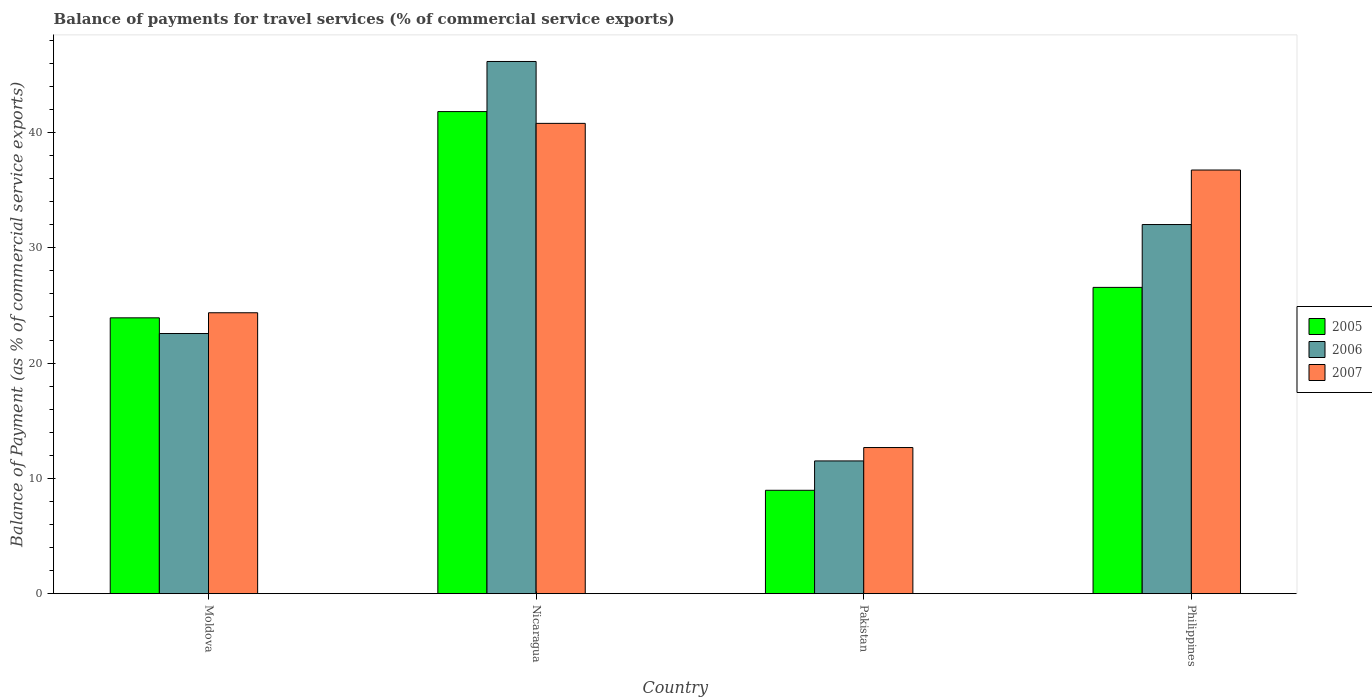Are the number of bars on each tick of the X-axis equal?
Provide a short and direct response. Yes. How many bars are there on the 3rd tick from the left?
Provide a succinct answer. 3. What is the label of the 1st group of bars from the left?
Your answer should be very brief. Moldova. In how many cases, is the number of bars for a given country not equal to the number of legend labels?
Your response must be concise. 0. What is the balance of payments for travel services in 2005 in Nicaragua?
Provide a short and direct response. 41.81. Across all countries, what is the maximum balance of payments for travel services in 2005?
Your answer should be very brief. 41.81. Across all countries, what is the minimum balance of payments for travel services in 2005?
Your answer should be very brief. 8.97. In which country was the balance of payments for travel services in 2005 maximum?
Your response must be concise. Nicaragua. What is the total balance of payments for travel services in 2006 in the graph?
Keep it short and to the point. 112.25. What is the difference between the balance of payments for travel services in 2007 in Moldova and that in Philippines?
Offer a very short reply. -12.38. What is the difference between the balance of payments for travel services in 2007 in Philippines and the balance of payments for travel services in 2005 in Moldova?
Your answer should be very brief. 12.82. What is the average balance of payments for travel services in 2006 per country?
Offer a terse response. 28.06. What is the difference between the balance of payments for travel services of/in 2007 and balance of payments for travel services of/in 2006 in Pakistan?
Offer a very short reply. 1.16. In how many countries, is the balance of payments for travel services in 2006 greater than 6 %?
Your answer should be very brief. 4. What is the ratio of the balance of payments for travel services in 2005 in Pakistan to that in Philippines?
Offer a terse response. 0.34. Is the balance of payments for travel services in 2005 in Pakistan less than that in Philippines?
Keep it short and to the point. Yes. What is the difference between the highest and the second highest balance of payments for travel services in 2005?
Provide a succinct answer. 15.25. What is the difference between the highest and the lowest balance of payments for travel services in 2005?
Provide a short and direct response. 32.85. In how many countries, is the balance of payments for travel services in 2007 greater than the average balance of payments for travel services in 2007 taken over all countries?
Make the answer very short. 2. Is the sum of the balance of payments for travel services in 2007 in Pakistan and Philippines greater than the maximum balance of payments for travel services in 2006 across all countries?
Give a very brief answer. Yes. What does the 3rd bar from the right in Philippines represents?
Ensure brevity in your answer.  2005. Is it the case that in every country, the sum of the balance of payments for travel services in 2005 and balance of payments for travel services in 2007 is greater than the balance of payments for travel services in 2006?
Give a very brief answer. Yes. How many bars are there?
Keep it short and to the point. 12. What is the difference between two consecutive major ticks on the Y-axis?
Offer a very short reply. 10. Are the values on the major ticks of Y-axis written in scientific E-notation?
Your response must be concise. No. Does the graph contain any zero values?
Offer a terse response. No. Does the graph contain grids?
Your answer should be compact. No. How are the legend labels stacked?
Make the answer very short. Vertical. What is the title of the graph?
Provide a succinct answer. Balance of payments for travel services (% of commercial service exports). What is the label or title of the X-axis?
Offer a very short reply. Country. What is the label or title of the Y-axis?
Your response must be concise. Balance of Payment (as % of commercial service exports). What is the Balance of Payment (as % of commercial service exports) of 2005 in Moldova?
Give a very brief answer. 23.92. What is the Balance of Payment (as % of commercial service exports) in 2006 in Moldova?
Provide a short and direct response. 22.56. What is the Balance of Payment (as % of commercial service exports) of 2007 in Moldova?
Offer a very short reply. 24.36. What is the Balance of Payment (as % of commercial service exports) in 2005 in Nicaragua?
Keep it short and to the point. 41.81. What is the Balance of Payment (as % of commercial service exports) in 2006 in Nicaragua?
Your response must be concise. 46.16. What is the Balance of Payment (as % of commercial service exports) in 2007 in Nicaragua?
Make the answer very short. 40.79. What is the Balance of Payment (as % of commercial service exports) of 2005 in Pakistan?
Provide a short and direct response. 8.97. What is the Balance of Payment (as % of commercial service exports) in 2006 in Pakistan?
Offer a terse response. 11.51. What is the Balance of Payment (as % of commercial service exports) of 2007 in Pakistan?
Provide a succinct answer. 12.67. What is the Balance of Payment (as % of commercial service exports) in 2005 in Philippines?
Your response must be concise. 26.56. What is the Balance of Payment (as % of commercial service exports) of 2006 in Philippines?
Keep it short and to the point. 32.02. What is the Balance of Payment (as % of commercial service exports) in 2007 in Philippines?
Ensure brevity in your answer.  36.74. Across all countries, what is the maximum Balance of Payment (as % of commercial service exports) in 2005?
Your response must be concise. 41.81. Across all countries, what is the maximum Balance of Payment (as % of commercial service exports) of 2006?
Your response must be concise. 46.16. Across all countries, what is the maximum Balance of Payment (as % of commercial service exports) in 2007?
Your response must be concise. 40.79. Across all countries, what is the minimum Balance of Payment (as % of commercial service exports) of 2005?
Provide a succinct answer. 8.97. Across all countries, what is the minimum Balance of Payment (as % of commercial service exports) in 2006?
Provide a short and direct response. 11.51. Across all countries, what is the minimum Balance of Payment (as % of commercial service exports) in 2007?
Ensure brevity in your answer.  12.67. What is the total Balance of Payment (as % of commercial service exports) in 2005 in the graph?
Your answer should be very brief. 101.26. What is the total Balance of Payment (as % of commercial service exports) of 2006 in the graph?
Provide a succinct answer. 112.25. What is the total Balance of Payment (as % of commercial service exports) in 2007 in the graph?
Give a very brief answer. 114.57. What is the difference between the Balance of Payment (as % of commercial service exports) of 2005 in Moldova and that in Nicaragua?
Provide a succinct answer. -17.89. What is the difference between the Balance of Payment (as % of commercial service exports) of 2006 in Moldova and that in Nicaragua?
Offer a very short reply. -23.59. What is the difference between the Balance of Payment (as % of commercial service exports) of 2007 in Moldova and that in Nicaragua?
Make the answer very short. -16.43. What is the difference between the Balance of Payment (as % of commercial service exports) of 2005 in Moldova and that in Pakistan?
Provide a succinct answer. 14.96. What is the difference between the Balance of Payment (as % of commercial service exports) of 2006 in Moldova and that in Pakistan?
Provide a succinct answer. 11.05. What is the difference between the Balance of Payment (as % of commercial service exports) in 2007 in Moldova and that in Pakistan?
Provide a succinct answer. 11.69. What is the difference between the Balance of Payment (as % of commercial service exports) in 2005 in Moldova and that in Philippines?
Make the answer very short. -2.64. What is the difference between the Balance of Payment (as % of commercial service exports) of 2006 in Moldova and that in Philippines?
Make the answer very short. -9.45. What is the difference between the Balance of Payment (as % of commercial service exports) of 2007 in Moldova and that in Philippines?
Ensure brevity in your answer.  -12.38. What is the difference between the Balance of Payment (as % of commercial service exports) in 2005 in Nicaragua and that in Pakistan?
Make the answer very short. 32.85. What is the difference between the Balance of Payment (as % of commercial service exports) in 2006 in Nicaragua and that in Pakistan?
Provide a short and direct response. 34.64. What is the difference between the Balance of Payment (as % of commercial service exports) of 2007 in Nicaragua and that in Pakistan?
Your answer should be compact. 28.12. What is the difference between the Balance of Payment (as % of commercial service exports) of 2005 in Nicaragua and that in Philippines?
Your answer should be very brief. 15.25. What is the difference between the Balance of Payment (as % of commercial service exports) in 2006 in Nicaragua and that in Philippines?
Offer a terse response. 14.14. What is the difference between the Balance of Payment (as % of commercial service exports) of 2007 in Nicaragua and that in Philippines?
Ensure brevity in your answer.  4.05. What is the difference between the Balance of Payment (as % of commercial service exports) in 2005 in Pakistan and that in Philippines?
Keep it short and to the point. -17.6. What is the difference between the Balance of Payment (as % of commercial service exports) of 2006 in Pakistan and that in Philippines?
Make the answer very short. -20.5. What is the difference between the Balance of Payment (as % of commercial service exports) in 2007 in Pakistan and that in Philippines?
Offer a very short reply. -24.07. What is the difference between the Balance of Payment (as % of commercial service exports) in 2005 in Moldova and the Balance of Payment (as % of commercial service exports) in 2006 in Nicaragua?
Offer a terse response. -22.23. What is the difference between the Balance of Payment (as % of commercial service exports) in 2005 in Moldova and the Balance of Payment (as % of commercial service exports) in 2007 in Nicaragua?
Offer a terse response. -16.87. What is the difference between the Balance of Payment (as % of commercial service exports) of 2006 in Moldova and the Balance of Payment (as % of commercial service exports) of 2007 in Nicaragua?
Provide a succinct answer. -18.23. What is the difference between the Balance of Payment (as % of commercial service exports) of 2005 in Moldova and the Balance of Payment (as % of commercial service exports) of 2006 in Pakistan?
Provide a short and direct response. 12.41. What is the difference between the Balance of Payment (as % of commercial service exports) of 2005 in Moldova and the Balance of Payment (as % of commercial service exports) of 2007 in Pakistan?
Your answer should be very brief. 11.25. What is the difference between the Balance of Payment (as % of commercial service exports) of 2006 in Moldova and the Balance of Payment (as % of commercial service exports) of 2007 in Pakistan?
Your answer should be compact. 9.89. What is the difference between the Balance of Payment (as % of commercial service exports) of 2005 in Moldova and the Balance of Payment (as % of commercial service exports) of 2006 in Philippines?
Give a very brief answer. -8.09. What is the difference between the Balance of Payment (as % of commercial service exports) of 2005 in Moldova and the Balance of Payment (as % of commercial service exports) of 2007 in Philippines?
Provide a succinct answer. -12.82. What is the difference between the Balance of Payment (as % of commercial service exports) of 2006 in Moldova and the Balance of Payment (as % of commercial service exports) of 2007 in Philippines?
Provide a short and direct response. -14.18. What is the difference between the Balance of Payment (as % of commercial service exports) in 2005 in Nicaragua and the Balance of Payment (as % of commercial service exports) in 2006 in Pakistan?
Your answer should be compact. 30.3. What is the difference between the Balance of Payment (as % of commercial service exports) of 2005 in Nicaragua and the Balance of Payment (as % of commercial service exports) of 2007 in Pakistan?
Your response must be concise. 29.14. What is the difference between the Balance of Payment (as % of commercial service exports) in 2006 in Nicaragua and the Balance of Payment (as % of commercial service exports) in 2007 in Pakistan?
Keep it short and to the point. 33.48. What is the difference between the Balance of Payment (as % of commercial service exports) of 2005 in Nicaragua and the Balance of Payment (as % of commercial service exports) of 2006 in Philippines?
Make the answer very short. 9.8. What is the difference between the Balance of Payment (as % of commercial service exports) of 2005 in Nicaragua and the Balance of Payment (as % of commercial service exports) of 2007 in Philippines?
Your answer should be very brief. 5.07. What is the difference between the Balance of Payment (as % of commercial service exports) of 2006 in Nicaragua and the Balance of Payment (as % of commercial service exports) of 2007 in Philippines?
Your response must be concise. 9.41. What is the difference between the Balance of Payment (as % of commercial service exports) in 2005 in Pakistan and the Balance of Payment (as % of commercial service exports) in 2006 in Philippines?
Ensure brevity in your answer.  -23.05. What is the difference between the Balance of Payment (as % of commercial service exports) of 2005 in Pakistan and the Balance of Payment (as % of commercial service exports) of 2007 in Philippines?
Offer a very short reply. -27.78. What is the difference between the Balance of Payment (as % of commercial service exports) of 2006 in Pakistan and the Balance of Payment (as % of commercial service exports) of 2007 in Philippines?
Provide a short and direct response. -25.23. What is the average Balance of Payment (as % of commercial service exports) of 2005 per country?
Make the answer very short. 25.32. What is the average Balance of Payment (as % of commercial service exports) of 2006 per country?
Your answer should be very brief. 28.06. What is the average Balance of Payment (as % of commercial service exports) of 2007 per country?
Give a very brief answer. 28.64. What is the difference between the Balance of Payment (as % of commercial service exports) in 2005 and Balance of Payment (as % of commercial service exports) in 2006 in Moldova?
Your answer should be very brief. 1.36. What is the difference between the Balance of Payment (as % of commercial service exports) of 2005 and Balance of Payment (as % of commercial service exports) of 2007 in Moldova?
Offer a very short reply. -0.44. What is the difference between the Balance of Payment (as % of commercial service exports) of 2006 and Balance of Payment (as % of commercial service exports) of 2007 in Moldova?
Give a very brief answer. -1.8. What is the difference between the Balance of Payment (as % of commercial service exports) of 2005 and Balance of Payment (as % of commercial service exports) of 2006 in Nicaragua?
Give a very brief answer. -4.34. What is the difference between the Balance of Payment (as % of commercial service exports) of 2006 and Balance of Payment (as % of commercial service exports) of 2007 in Nicaragua?
Provide a short and direct response. 5.37. What is the difference between the Balance of Payment (as % of commercial service exports) of 2005 and Balance of Payment (as % of commercial service exports) of 2006 in Pakistan?
Give a very brief answer. -2.55. What is the difference between the Balance of Payment (as % of commercial service exports) of 2005 and Balance of Payment (as % of commercial service exports) of 2007 in Pakistan?
Offer a terse response. -3.71. What is the difference between the Balance of Payment (as % of commercial service exports) in 2006 and Balance of Payment (as % of commercial service exports) in 2007 in Pakistan?
Provide a succinct answer. -1.16. What is the difference between the Balance of Payment (as % of commercial service exports) of 2005 and Balance of Payment (as % of commercial service exports) of 2006 in Philippines?
Give a very brief answer. -5.45. What is the difference between the Balance of Payment (as % of commercial service exports) in 2005 and Balance of Payment (as % of commercial service exports) in 2007 in Philippines?
Your answer should be very brief. -10.18. What is the difference between the Balance of Payment (as % of commercial service exports) in 2006 and Balance of Payment (as % of commercial service exports) in 2007 in Philippines?
Keep it short and to the point. -4.73. What is the ratio of the Balance of Payment (as % of commercial service exports) in 2005 in Moldova to that in Nicaragua?
Your response must be concise. 0.57. What is the ratio of the Balance of Payment (as % of commercial service exports) of 2006 in Moldova to that in Nicaragua?
Offer a terse response. 0.49. What is the ratio of the Balance of Payment (as % of commercial service exports) in 2007 in Moldova to that in Nicaragua?
Your answer should be compact. 0.6. What is the ratio of the Balance of Payment (as % of commercial service exports) of 2005 in Moldova to that in Pakistan?
Your answer should be compact. 2.67. What is the ratio of the Balance of Payment (as % of commercial service exports) of 2006 in Moldova to that in Pakistan?
Give a very brief answer. 1.96. What is the ratio of the Balance of Payment (as % of commercial service exports) of 2007 in Moldova to that in Pakistan?
Your answer should be very brief. 1.92. What is the ratio of the Balance of Payment (as % of commercial service exports) in 2005 in Moldova to that in Philippines?
Your answer should be very brief. 0.9. What is the ratio of the Balance of Payment (as % of commercial service exports) in 2006 in Moldova to that in Philippines?
Provide a short and direct response. 0.7. What is the ratio of the Balance of Payment (as % of commercial service exports) of 2007 in Moldova to that in Philippines?
Your response must be concise. 0.66. What is the ratio of the Balance of Payment (as % of commercial service exports) in 2005 in Nicaragua to that in Pakistan?
Provide a short and direct response. 4.66. What is the ratio of the Balance of Payment (as % of commercial service exports) of 2006 in Nicaragua to that in Pakistan?
Your answer should be very brief. 4.01. What is the ratio of the Balance of Payment (as % of commercial service exports) in 2007 in Nicaragua to that in Pakistan?
Make the answer very short. 3.22. What is the ratio of the Balance of Payment (as % of commercial service exports) in 2005 in Nicaragua to that in Philippines?
Offer a terse response. 1.57. What is the ratio of the Balance of Payment (as % of commercial service exports) in 2006 in Nicaragua to that in Philippines?
Keep it short and to the point. 1.44. What is the ratio of the Balance of Payment (as % of commercial service exports) of 2007 in Nicaragua to that in Philippines?
Ensure brevity in your answer.  1.11. What is the ratio of the Balance of Payment (as % of commercial service exports) of 2005 in Pakistan to that in Philippines?
Give a very brief answer. 0.34. What is the ratio of the Balance of Payment (as % of commercial service exports) in 2006 in Pakistan to that in Philippines?
Your response must be concise. 0.36. What is the ratio of the Balance of Payment (as % of commercial service exports) of 2007 in Pakistan to that in Philippines?
Provide a succinct answer. 0.34. What is the difference between the highest and the second highest Balance of Payment (as % of commercial service exports) in 2005?
Ensure brevity in your answer.  15.25. What is the difference between the highest and the second highest Balance of Payment (as % of commercial service exports) in 2006?
Offer a terse response. 14.14. What is the difference between the highest and the second highest Balance of Payment (as % of commercial service exports) of 2007?
Ensure brevity in your answer.  4.05. What is the difference between the highest and the lowest Balance of Payment (as % of commercial service exports) of 2005?
Offer a terse response. 32.85. What is the difference between the highest and the lowest Balance of Payment (as % of commercial service exports) in 2006?
Make the answer very short. 34.64. What is the difference between the highest and the lowest Balance of Payment (as % of commercial service exports) in 2007?
Offer a terse response. 28.12. 